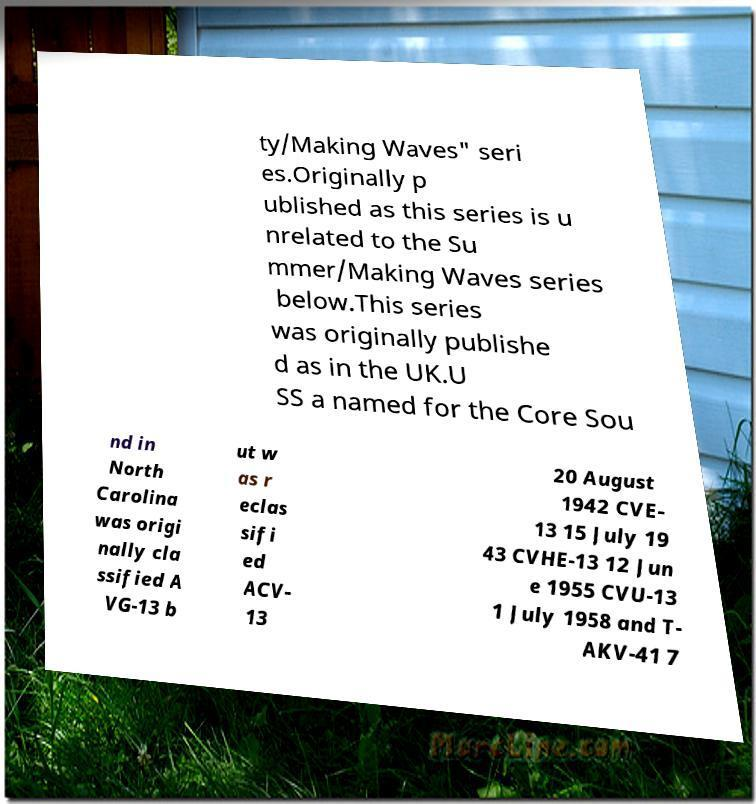There's text embedded in this image that I need extracted. Can you transcribe it verbatim? ty/Making Waves" seri es.Originally p ublished as this series is u nrelated to the Su mmer/Making Waves series below.This series was originally publishe d as in the UK.U SS a named for the Core Sou nd in North Carolina was origi nally cla ssified A VG-13 b ut w as r eclas sifi ed ACV- 13 20 August 1942 CVE- 13 15 July 19 43 CVHE-13 12 Jun e 1955 CVU-13 1 July 1958 and T- AKV-41 7 